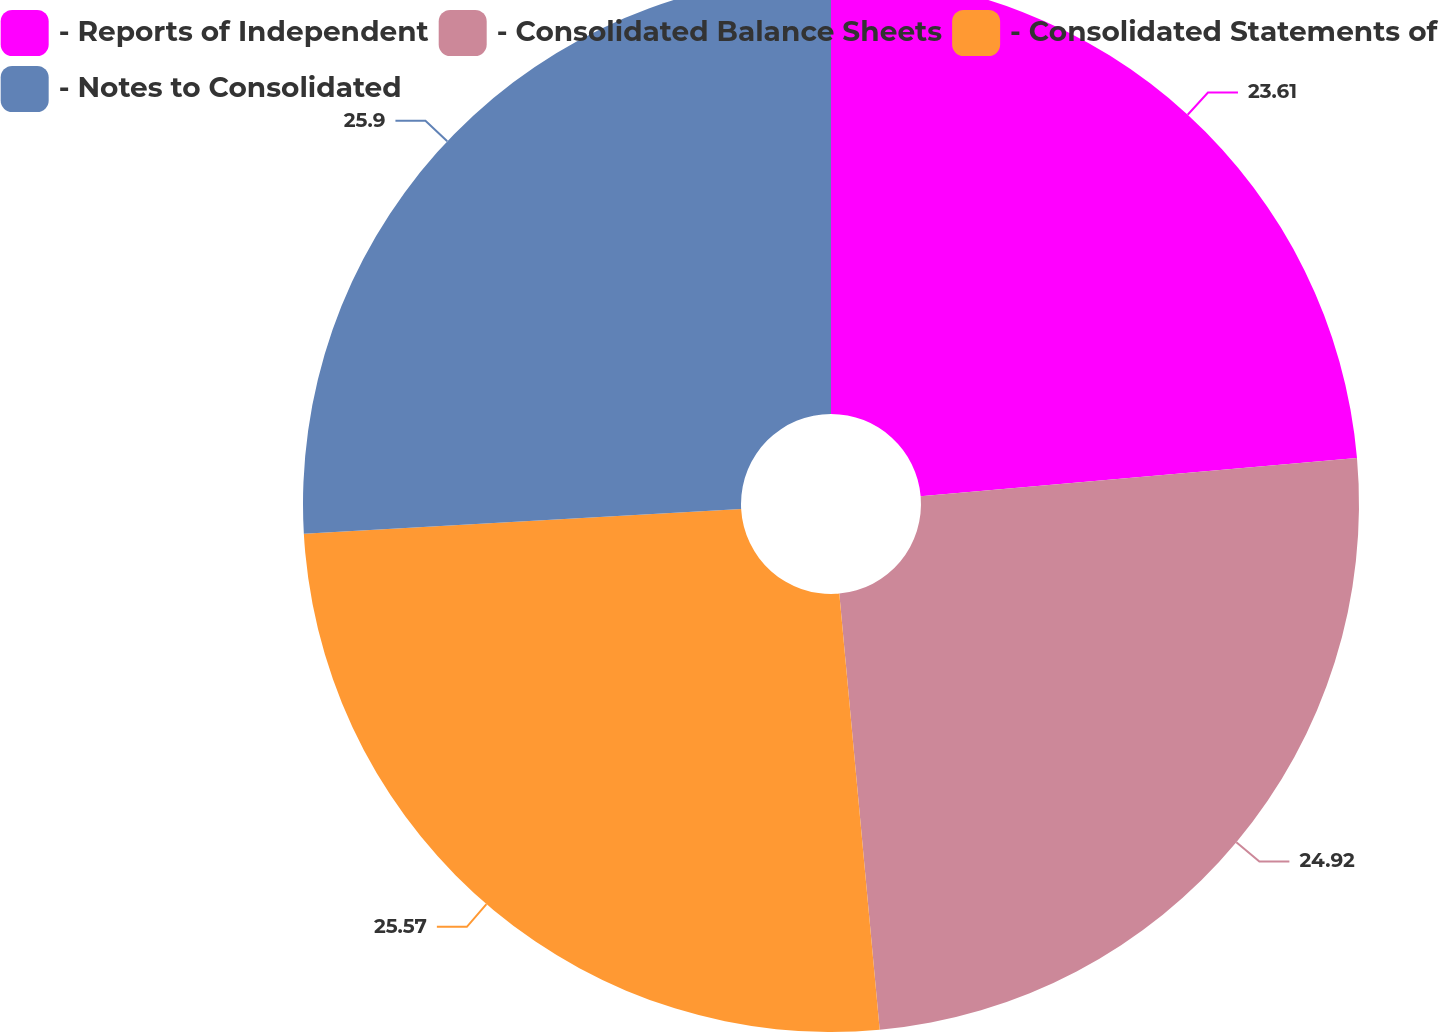Convert chart. <chart><loc_0><loc_0><loc_500><loc_500><pie_chart><fcel>- Reports of Independent<fcel>- Consolidated Balance Sheets<fcel>- Consolidated Statements of<fcel>- Notes to Consolidated<nl><fcel>23.61%<fcel>24.92%<fcel>25.57%<fcel>25.9%<nl></chart> 